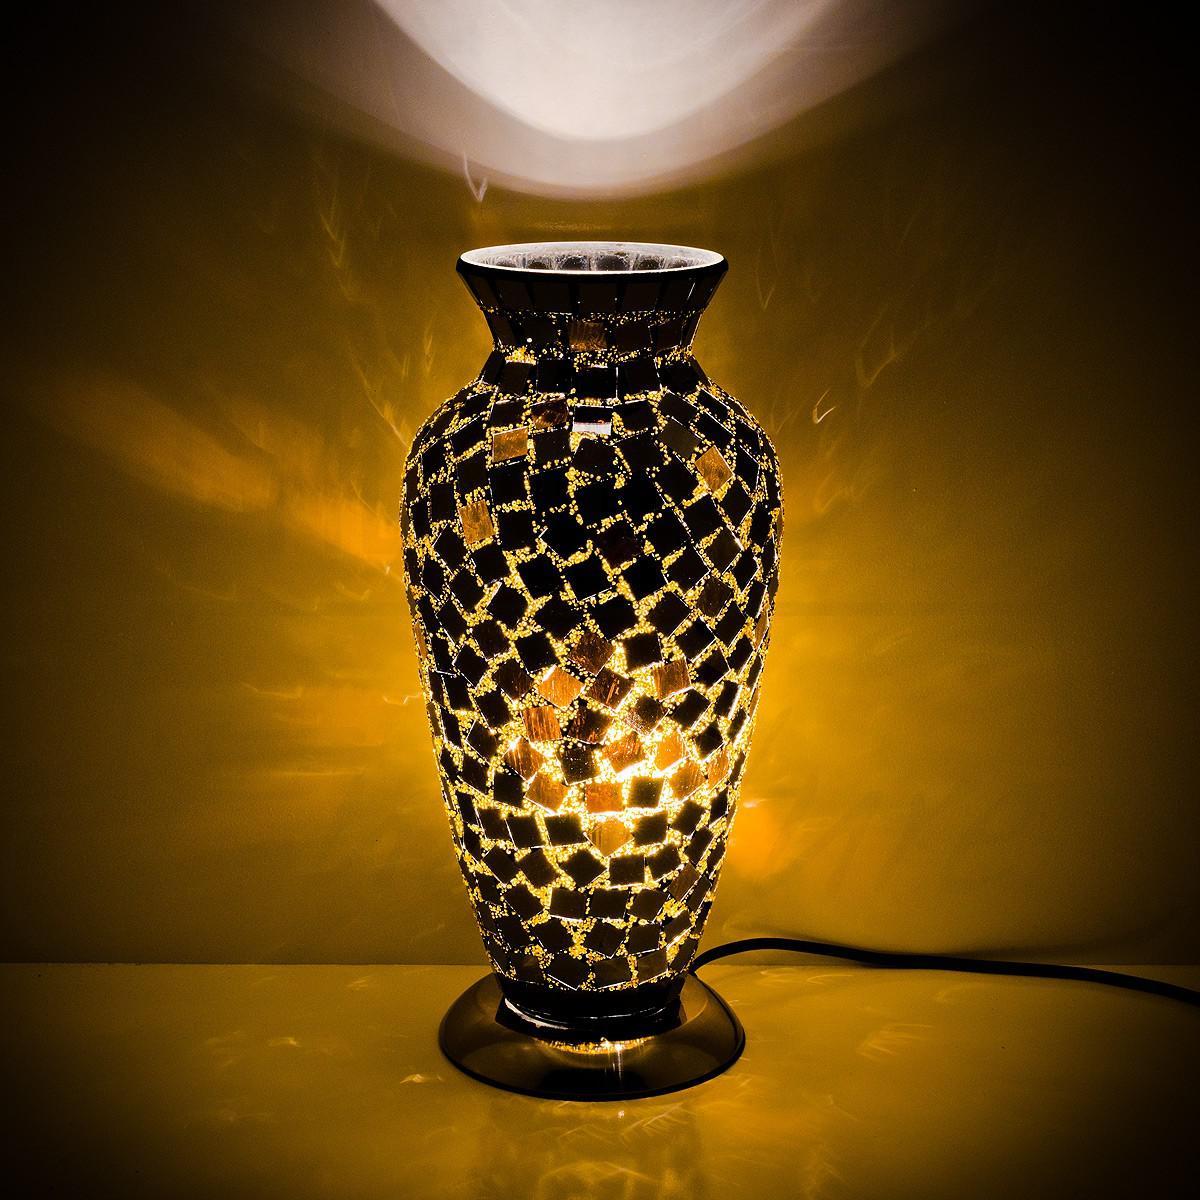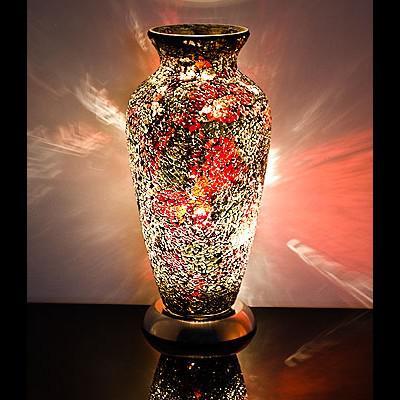The first image is the image on the left, the second image is the image on the right. Considering the images on both sides, is "A vase is displayed against a plain black background." valid? Answer yes or no. No. The first image is the image on the left, the second image is the image on the right. Examine the images to the left and right. Is the description "One lamp is shaped like an urn with a solid black base, while a second lamp has a rounded lower half that narrows before flaring slightly at the top, and sits on a silver base." accurate? Answer yes or no. No. 